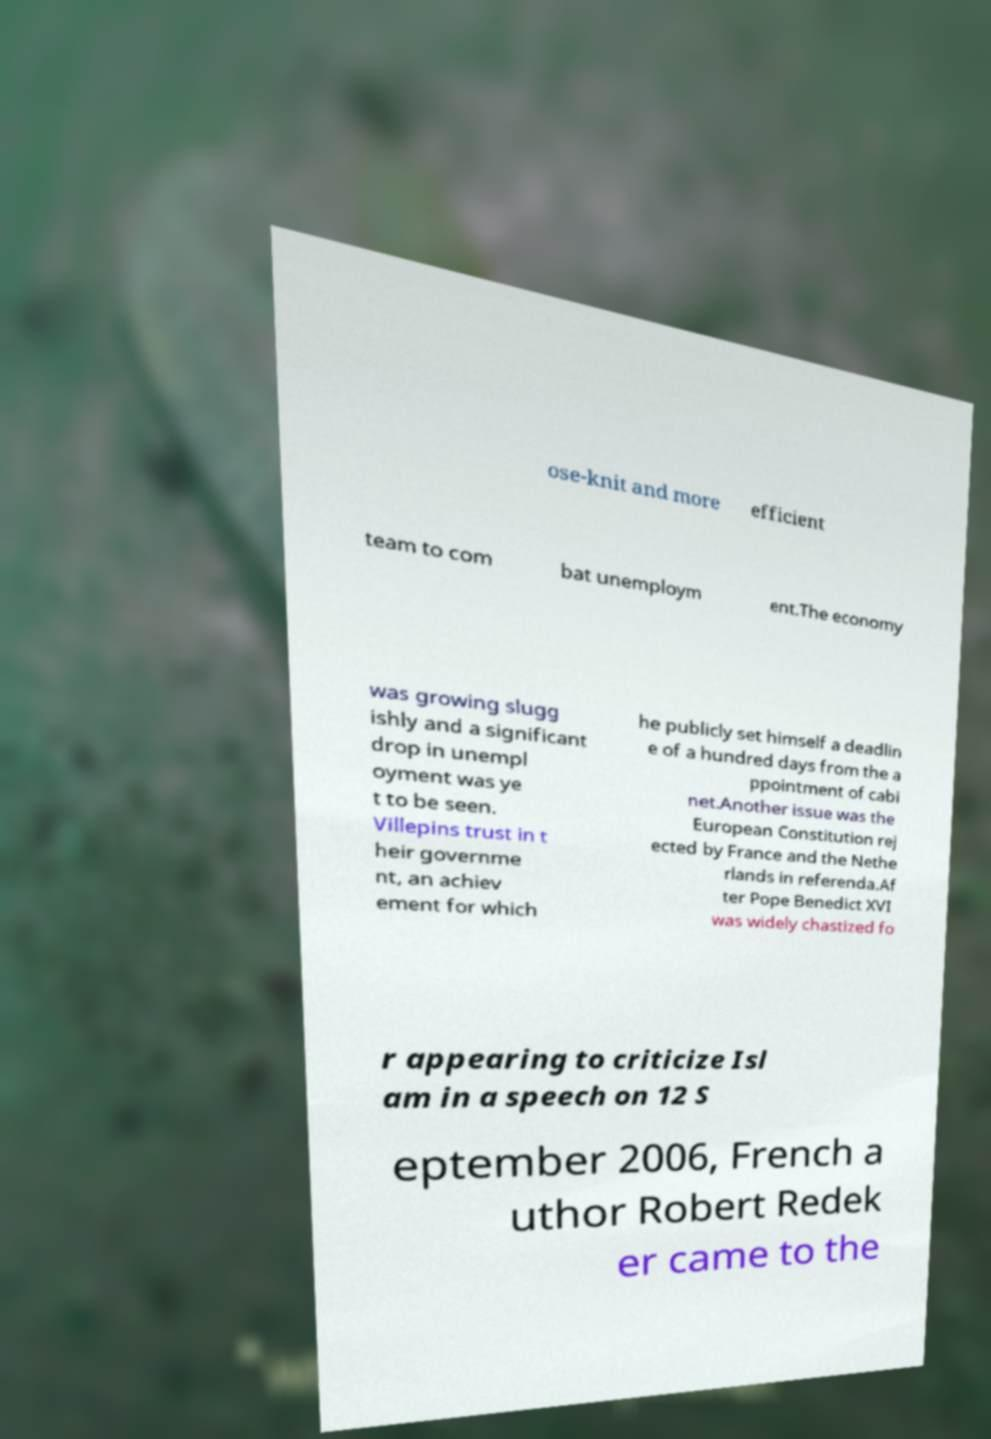Could you extract and type out the text from this image? ose-knit and more efficient team to com bat unemploym ent.The economy was growing slugg ishly and a significant drop in unempl oyment was ye t to be seen. Villepins trust in t heir governme nt, an achiev ement for which he publicly set himself a deadlin e of a hundred days from the a ppointment of cabi net.Another issue was the European Constitution rej ected by France and the Nethe rlands in referenda.Af ter Pope Benedict XVI was widely chastized fo r appearing to criticize Isl am in a speech on 12 S eptember 2006, French a uthor Robert Redek er came to the 